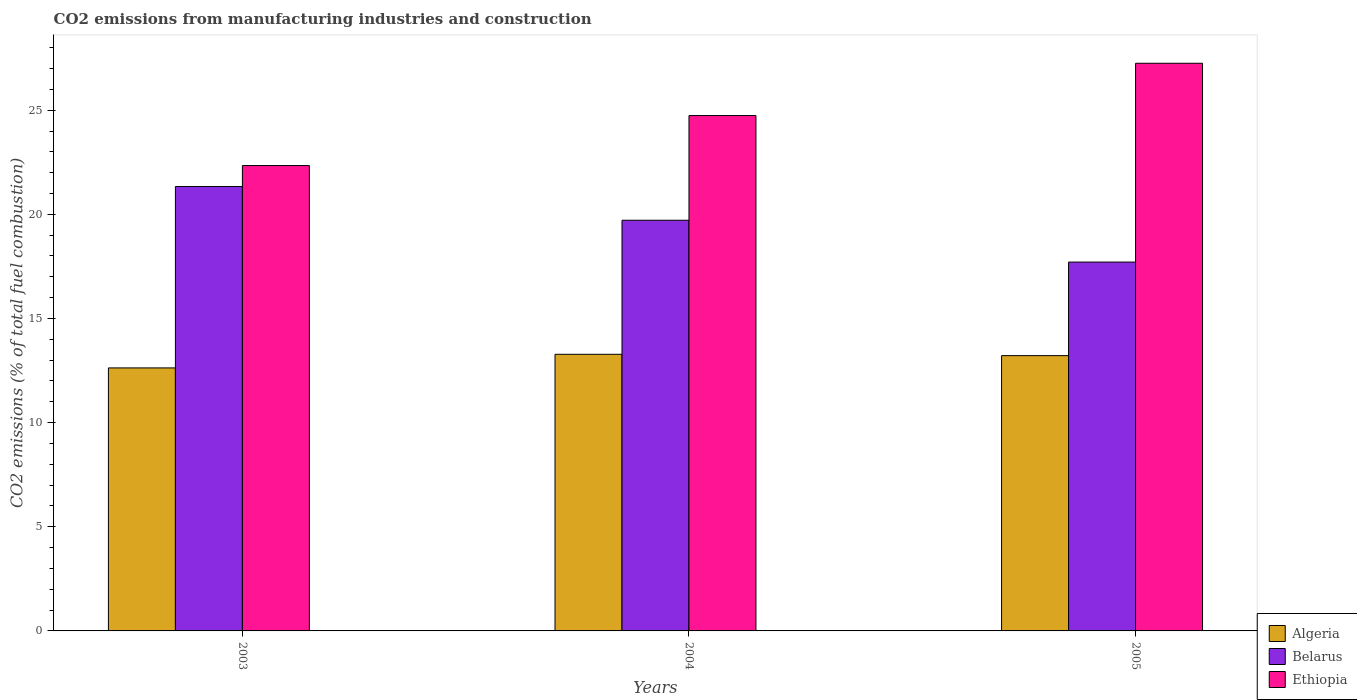How many bars are there on the 3rd tick from the left?
Provide a short and direct response. 3. What is the label of the 2nd group of bars from the left?
Offer a terse response. 2004. What is the amount of CO2 emitted in Belarus in 2005?
Your answer should be compact. 17.71. Across all years, what is the maximum amount of CO2 emitted in Belarus?
Ensure brevity in your answer.  21.34. Across all years, what is the minimum amount of CO2 emitted in Algeria?
Make the answer very short. 12.63. In which year was the amount of CO2 emitted in Ethiopia minimum?
Offer a terse response. 2003. What is the total amount of CO2 emitted in Belarus in the graph?
Offer a very short reply. 58.76. What is the difference between the amount of CO2 emitted in Algeria in 2004 and that in 2005?
Keep it short and to the point. 0.06. What is the difference between the amount of CO2 emitted in Belarus in 2003 and the amount of CO2 emitted in Algeria in 2005?
Make the answer very short. 8.12. What is the average amount of CO2 emitted in Algeria per year?
Keep it short and to the point. 13.04. In the year 2004, what is the difference between the amount of CO2 emitted in Algeria and amount of CO2 emitted in Ethiopia?
Your answer should be compact. -11.46. What is the ratio of the amount of CO2 emitted in Belarus in 2003 to that in 2005?
Ensure brevity in your answer.  1.2. Is the amount of CO2 emitted in Ethiopia in 2003 less than that in 2004?
Your answer should be compact. Yes. What is the difference between the highest and the second highest amount of CO2 emitted in Belarus?
Offer a terse response. 1.62. What is the difference between the highest and the lowest amount of CO2 emitted in Algeria?
Provide a succinct answer. 0.65. In how many years, is the amount of CO2 emitted in Belarus greater than the average amount of CO2 emitted in Belarus taken over all years?
Ensure brevity in your answer.  2. Is the sum of the amount of CO2 emitted in Ethiopia in 2004 and 2005 greater than the maximum amount of CO2 emitted in Algeria across all years?
Your response must be concise. Yes. What does the 2nd bar from the left in 2003 represents?
Offer a very short reply. Belarus. What does the 1st bar from the right in 2003 represents?
Ensure brevity in your answer.  Ethiopia. How many years are there in the graph?
Provide a short and direct response. 3. What is the difference between two consecutive major ticks on the Y-axis?
Offer a terse response. 5. Are the values on the major ticks of Y-axis written in scientific E-notation?
Ensure brevity in your answer.  No. Does the graph contain any zero values?
Provide a short and direct response. No. Does the graph contain grids?
Give a very brief answer. No. What is the title of the graph?
Keep it short and to the point. CO2 emissions from manufacturing industries and construction. What is the label or title of the Y-axis?
Keep it short and to the point. CO2 emissions (% of total fuel combustion). What is the CO2 emissions (% of total fuel combustion) of Algeria in 2003?
Your answer should be very brief. 12.63. What is the CO2 emissions (% of total fuel combustion) of Belarus in 2003?
Provide a short and direct response. 21.34. What is the CO2 emissions (% of total fuel combustion) of Ethiopia in 2003?
Your answer should be compact. 22.34. What is the CO2 emissions (% of total fuel combustion) of Algeria in 2004?
Keep it short and to the point. 13.28. What is the CO2 emissions (% of total fuel combustion) of Belarus in 2004?
Your answer should be compact. 19.72. What is the CO2 emissions (% of total fuel combustion) of Ethiopia in 2004?
Your answer should be very brief. 24.74. What is the CO2 emissions (% of total fuel combustion) in Algeria in 2005?
Your answer should be very brief. 13.22. What is the CO2 emissions (% of total fuel combustion) of Belarus in 2005?
Make the answer very short. 17.71. What is the CO2 emissions (% of total fuel combustion) of Ethiopia in 2005?
Your answer should be very brief. 27.25. Across all years, what is the maximum CO2 emissions (% of total fuel combustion) in Algeria?
Ensure brevity in your answer.  13.28. Across all years, what is the maximum CO2 emissions (% of total fuel combustion) in Belarus?
Keep it short and to the point. 21.34. Across all years, what is the maximum CO2 emissions (% of total fuel combustion) of Ethiopia?
Your response must be concise. 27.25. Across all years, what is the minimum CO2 emissions (% of total fuel combustion) in Algeria?
Make the answer very short. 12.63. Across all years, what is the minimum CO2 emissions (% of total fuel combustion) in Belarus?
Keep it short and to the point. 17.71. Across all years, what is the minimum CO2 emissions (% of total fuel combustion) of Ethiopia?
Make the answer very short. 22.34. What is the total CO2 emissions (% of total fuel combustion) in Algeria in the graph?
Provide a succinct answer. 39.12. What is the total CO2 emissions (% of total fuel combustion) in Belarus in the graph?
Your response must be concise. 58.76. What is the total CO2 emissions (% of total fuel combustion) of Ethiopia in the graph?
Give a very brief answer. 74.34. What is the difference between the CO2 emissions (% of total fuel combustion) of Algeria in 2003 and that in 2004?
Ensure brevity in your answer.  -0.65. What is the difference between the CO2 emissions (% of total fuel combustion) of Belarus in 2003 and that in 2004?
Ensure brevity in your answer.  1.62. What is the difference between the CO2 emissions (% of total fuel combustion) in Ethiopia in 2003 and that in 2004?
Your response must be concise. -2.4. What is the difference between the CO2 emissions (% of total fuel combustion) in Algeria in 2003 and that in 2005?
Your response must be concise. -0.59. What is the difference between the CO2 emissions (% of total fuel combustion) in Belarus in 2003 and that in 2005?
Make the answer very short. 3.63. What is the difference between the CO2 emissions (% of total fuel combustion) of Ethiopia in 2003 and that in 2005?
Give a very brief answer. -4.91. What is the difference between the CO2 emissions (% of total fuel combustion) in Algeria in 2004 and that in 2005?
Offer a terse response. 0.06. What is the difference between the CO2 emissions (% of total fuel combustion) of Belarus in 2004 and that in 2005?
Ensure brevity in your answer.  2.01. What is the difference between the CO2 emissions (% of total fuel combustion) in Ethiopia in 2004 and that in 2005?
Make the answer very short. -2.51. What is the difference between the CO2 emissions (% of total fuel combustion) of Algeria in 2003 and the CO2 emissions (% of total fuel combustion) of Belarus in 2004?
Your response must be concise. -7.09. What is the difference between the CO2 emissions (% of total fuel combustion) in Algeria in 2003 and the CO2 emissions (% of total fuel combustion) in Ethiopia in 2004?
Your answer should be very brief. -12.12. What is the difference between the CO2 emissions (% of total fuel combustion) of Belarus in 2003 and the CO2 emissions (% of total fuel combustion) of Ethiopia in 2004?
Make the answer very short. -3.41. What is the difference between the CO2 emissions (% of total fuel combustion) of Algeria in 2003 and the CO2 emissions (% of total fuel combustion) of Belarus in 2005?
Give a very brief answer. -5.08. What is the difference between the CO2 emissions (% of total fuel combustion) in Algeria in 2003 and the CO2 emissions (% of total fuel combustion) in Ethiopia in 2005?
Provide a short and direct response. -14.63. What is the difference between the CO2 emissions (% of total fuel combustion) of Belarus in 2003 and the CO2 emissions (% of total fuel combustion) of Ethiopia in 2005?
Ensure brevity in your answer.  -5.92. What is the difference between the CO2 emissions (% of total fuel combustion) of Algeria in 2004 and the CO2 emissions (% of total fuel combustion) of Belarus in 2005?
Keep it short and to the point. -4.43. What is the difference between the CO2 emissions (% of total fuel combustion) in Algeria in 2004 and the CO2 emissions (% of total fuel combustion) in Ethiopia in 2005?
Provide a short and direct response. -13.97. What is the difference between the CO2 emissions (% of total fuel combustion) of Belarus in 2004 and the CO2 emissions (% of total fuel combustion) of Ethiopia in 2005?
Provide a short and direct response. -7.54. What is the average CO2 emissions (% of total fuel combustion) of Algeria per year?
Ensure brevity in your answer.  13.04. What is the average CO2 emissions (% of total fuel combustion) in Belarus per year?
Ensure brevity in your answer.  19.59. What is the average CO2 emissions (% of total fuel combustion) in Ethiopia per year?
Provide a succinct answer. 24.78. In the year 2003, what is the difference between the CO2 emissions (% of total fuel combustion) in Algeria and CO2 emissions (% of total fuel combustion) in Belarus?
Offer a very short reply. -8.71. In the year 2003, what is the difference between the CO2 emissions (% of total fuel combustion) in Algeria and CO2 emissions (% of total fuel combustion) in Ethiopia?
Keep it short and to the point. -9.72. In the year 2003, what is the difference between the CO2 emissions (% of total fuel combustion) of Belarus and CO2 emissions (% of total fuel combustion) of Ethiopia?
Your answer should be very brief. -1.01. In the year 2004, what is the difference between the CO2 emissions (% of total fuel combustion) in Algeria and CO2 emissions (% of total fuel combustion) in Belarus?
Ensure brevity in your answer.  -6.44. In the year 2004, what is the difference between the CO2 emissions (% of total fuel combustion) in Algeria and CO2 emissions (% of total fuel combustion) in Ethiopia?
Offer a very short reply. -11.46. In the year 2004, what is the difference between the CO2 emissions (% of total fuel combustion) of Belarus and CO2 emissions (% of total fuel combustion) of Ethiopia?
Keep it short and to the point. -5.03. In the year 2005, what is the difference between the CO2 emissions (% of total fuel combustion) in Algeria and CO2 emissions (% of total fuel combustion) in Belarus?
Your answer should be compact. -4.49. In the year 2005, what is the difference between the CO2 emissions (% of total fuel combustion) in Algeria and CO2 emissions (% of total fuel combustion) in Ethiopia?
Give a very brief answer. -14.04. In the year 2005, what is the difference between the CO2 emissions (% of total fuel combustion) of Belarus and CO2 emissions (% of total fuel combustion) of Ethiopia?
Make the answer very short. -9.54. What is the ratio of the CO2 emissions (% of total fuel combustion) of Algeria in 2003 to that in 2004?
Give a very brief answer. 0.95. What is the ratio of the CO2 emissions (% of total fuel combustion) in Belarus in 2003 to that in 2004?
Provide a succinct answer. 1.08. What is the ratio of the CO2 emissions (% of total fuel combustion) of Ethiopia in 2003 to that in 2004?
Ensure brevity in your answer.  0.9. What is the ratio of the CO2 emissions (% of total fuel combustion) of Algeria in 2003 to that in 2005?
Keep it short and to the point. 0.96. What is the ratio of the CO2 emissions (% of total fuel combustion) of Belarus in 2003 to that in 2005?
Provide a succinct answer. 1.2. What is the ratio of the CO2 emissions (% of total fuel combustion) of Ethiopia in 2003 to that in 2005?
Offer a very short reply. 0.82. What is the ratio of the CO2 emissions (% of total fuel combustion) in Algeria in 2004 to that in 2005?
Your answer should be compact. 1. What is the ratio of the CO2 emissions (% of total fuel combustion) in Belarus in 2004 to that in 2005?
Your answer should be very brief. 1.11. What is the ratio of the CO2 emissions (% of total fuel combustion) in Ethiopia in 2004 to that in 2005?
Provide a short and direct response. 0.91. What is the difference between the highest and the second highest CO2 emissions (% of total fuel combustion) of Algeria?
Keep it short and to the point. 0.06. What is the difference between the highest and the second highest CO2 emissions (% of total fuel combustion) in Belarus?
Make the answer very short. 1.62. What is the difference between the highest and the second highest CO2 emissions (% of total fuel combustion) of Ethiopia?
Offer a terse response. 2.51. What is the difference between the highest and the lowest CO2 emissions (% of total fuel combustion) in Algeria?
Give a very brief answer. 0.65. What is the difference between the highest and the lowest CO2 emissions (% of total fuel combustion) of Belarus?
Give a very brief answer. 3.63. What is the difference between the highest and the lowest CO2 emissions (% of total fuel combustion) of Ethiopia?
Provide a short and direct response. 4.91. 